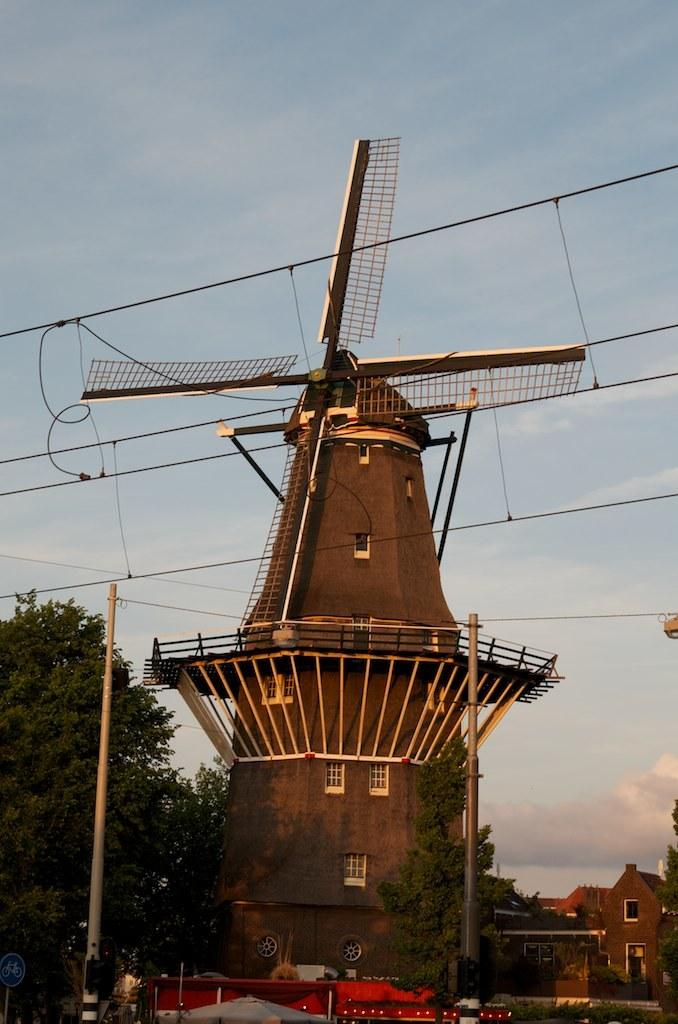What is the main structure visible in the image? There is a windmill in the image. What other types of buildings can be seen in the image? There are homes in the image. How does the windmill taste in the image? The windmill is not something that can be tasted; it is a structure. 